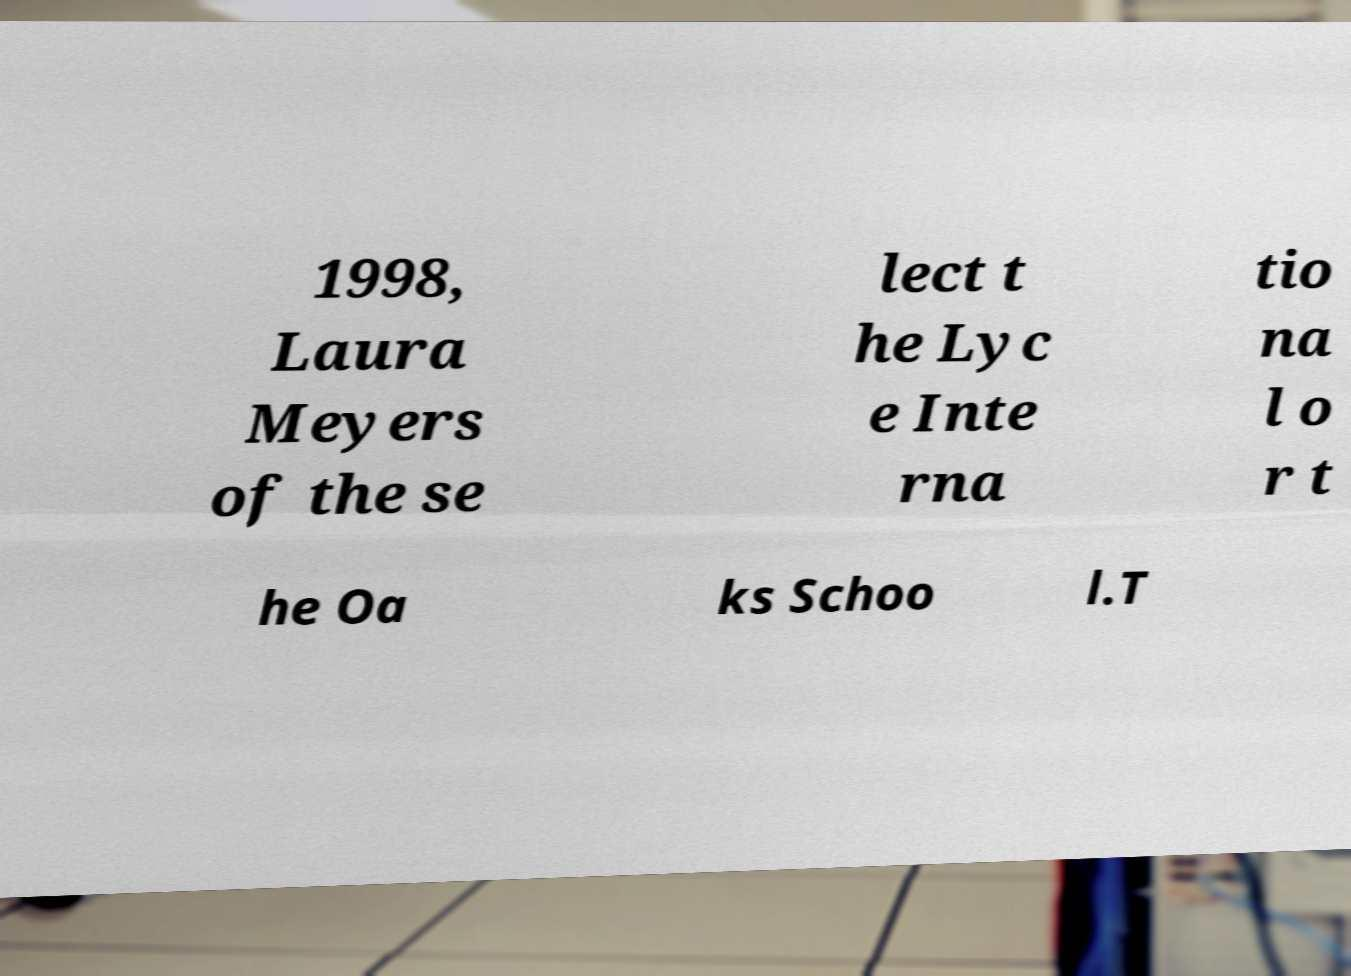Could you assist in decoding the text presented in this image and type it out clearly? 1998, Laura Meyers of the se lect t he Lyc e Inte rna tio na l o r t he Oa ks Schoo l.T 